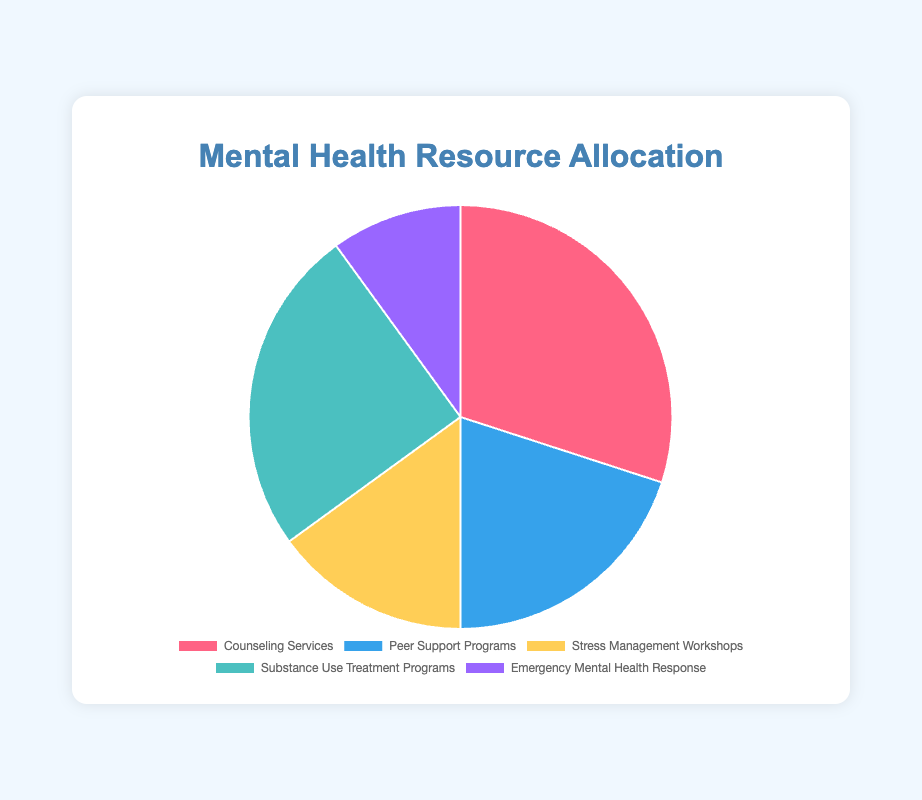What percentage of resources is allocated to Substance Use Treatment Programs? Based on the data provided in the figure, Substance Use Treatment Programs are allocated 25% of the resources.
Answer: 25% Which two resources have the highest allocation percentages? The highest allocation is 30% for Counseling Services, followed by 25% for Substance Use Treatment Programs.
Answer: Counseling Services and Substance Use Treatment Programs What is the combined percentage allocation for Counseling Services and Stress Management Workshops? Add the percentages of Counseling Services (30%) and Stress Management Workshops (15%): 30% + 15% = 45%.
Answer: 45% Which resource has the lowest allocation percentage, and what is it? The lowest allocation is for Emergency Mental Health Response, which is 10%.
Answer: Emergency Mental Health Response, 10% How much higher is the percentage allocation for Peer Support Programs compared to Emergency Mental Health Response? Subtract the percentage for Emergency Mental Health Response (10%) from Peer Support Programs (20%): 20% - 10% = 10%.
Answer: 10% What is the difference in allocation between Counseling Services and Substance Use Treatment Programs? Counseling Services are allocated 30%, and Substance Use Treatment Programs are allocated 25%. The difference is 30% - 25% = 5%.
Answer: 5% Which resource is represented by the blue color in the pie chart? The blue color in the pie chart represents Peer Support Programs.
Answer: Peer Support Programs What percentage more is allocated to Substance Use Treatment Programs than to Stress Management Workshops? The allocation for Substance Use Treatment Programs is 25%, and for Stress Management Workshops, it is 15%. The difference is 25% - 15% = 10%.
Answer: 10% What are the total allocations for Peer Support Programs and Emergency Mental Health Response combined? Add the percentages of Peer Support Programs (20%) and Emergency Mental Health Response (10%): 20% + 10% = 30%.
Answer: 30% 